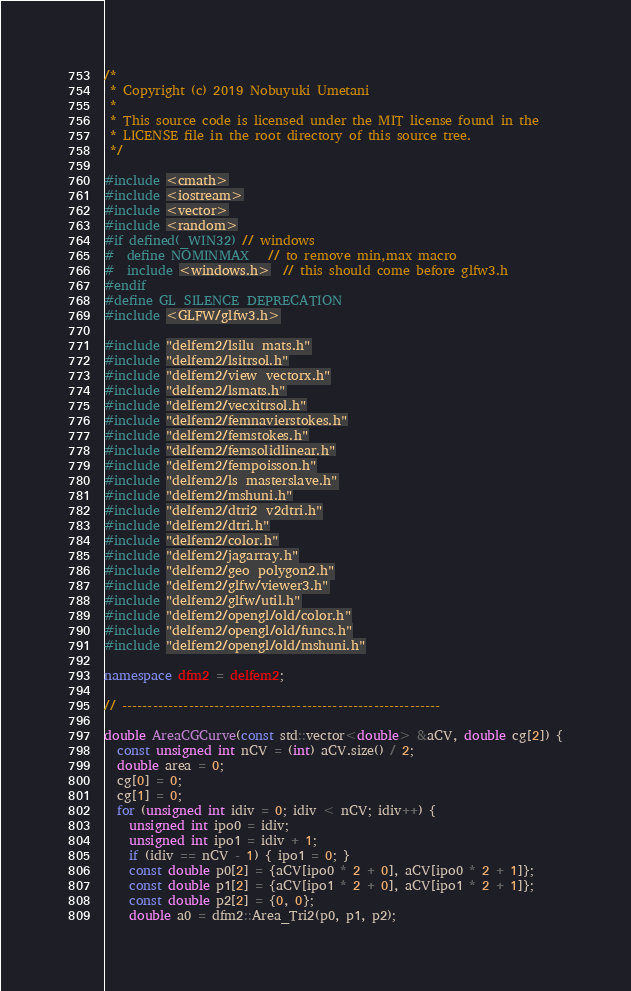Convert code to text. <code><loc_0><loc_0><loc_500><loc_500><_C++_>/*
 * Copyright (c) 2019 Nobuyuki Umetani
 *
 * This source code is licensed under the MIT license found in the
 * LICENSE file in the root directory of this source tree.
 */

#include <cmath>
#include <iostream>
#include <vector>
#include <random>
#if defined(_WIN32) // windows
#  define NOMINMAX   // to remove min,max macro
#  include <windows.h>  // this should come before glfw3.h
#endif
#define GL_SILENCE_DEPRECATION
#include <GLFW/glfw3.h>

#include "delfem2/lsilu_mats.h"
#include "delfem2/lsitrsol.h"
#include "delfem2/view_vectorx.h"
#include "delfem2/lsmats.h"
#include "delfem2/vecxitrsol.h"
#include "delfem2/femnavierstokes.h"
#include "delfem2/femstokes.h"
#include "delfem2/femsolidlinear.h"
#include "delfem2/fempoisson.h"
#include "delfem2/ls_masterslave.h"
#include "delfem2/mshuni.h"
#include "delfem2/dtri2_v2dtri.h"
#include "delfem2/dtri.h"
#include "delfem2/color.h"
#include "delfem2/jagarray.h"
#include "delfem2/geo_polygon2.h"
#include "delfem2/glfw/viewer3.h"
#include "delfem2/glfw/util.h"
#include "delfem2/opengl/old/color.h"
#include "delfem2/opengl/old/funcs.h"
#include "delfem2/opengl/old/mshuni.h"

namespace dfm2 = delfem2;

// --------------------------------------------------------------

double AreaCGCurve(const std::vector<double> &aCV, double cg[2]) {
  const unsigned int nCV = (int) aCV.size() / 2;
  double area = 0;
  cg[0] = 0;
  cg[1] = 0;
  for (unsigned int idiv = 0; idiv < nCV; idiv++) {
    unsigned int ipo0 = idiv;
    unsigned int ipo1 = idiv + 1;
    if (idiv == nCV - 1) { ipo1 = 0; }
    const double p0[2] = {aCV[ipo0 * 2 + 0], aCV[ipo0 * 2 + 1]};
    const double p1[2] = {aCV[ipo1 * 2 + 0], aCV[ipo1 * 2 + 1]};
    const double p2[2] = {0, 0};
    double a0 = dfm2::Area_Tri2(p0, p1, p2);</code> 